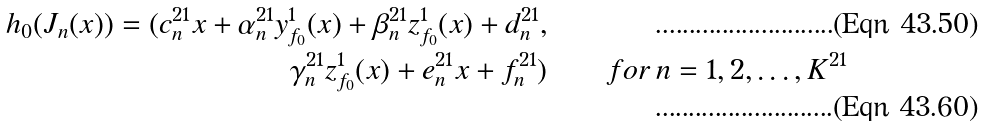<formula> <loc_0><loc_0><loc_500><loc_500>h _ { 0 } ( J _ { n } ( x ) ) = ( c _ { n } ^ { 2 1 } x + \alpha _ { n } ^ { 2 1 } y _ { f _ { 0 } } ^ { 1 } ( x ) + \beta _ { n } ^ { 2 1 } z _ { f _ { 0 } } ^ { 1 } ( x ) + d _ { n } ^ { 2 1 } , & & \\ \gamma _ { n } ^ { 2 1 } z _ { f _ { 0 } } ^ { 1 } ( x ) + e _ { n } ^ { 2 1 } x + f _ { n } ^ { 2 1 } ) & & \, f o r \, n = 1 , 2 , \dots , K ^ { 2 1 }</formula> 